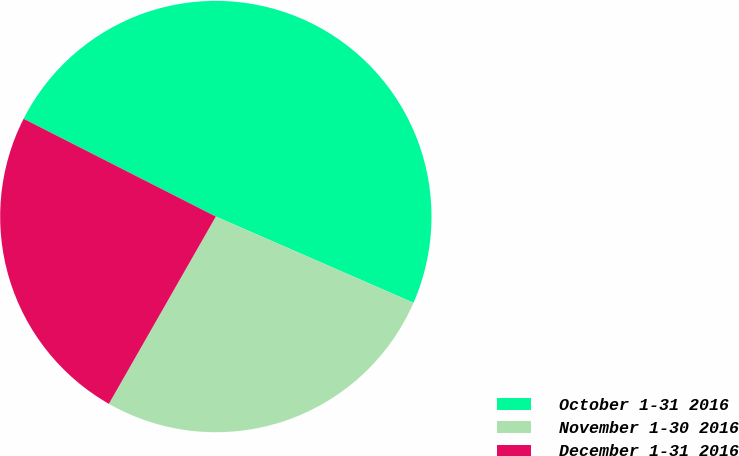Convert chart to OTSL. <chart><loc_0><loc_0><loc_500><loc_500><pie_chart><fcel>October 1-31 2016<fcel>November 1-30 2016<fcel>December 1-31 2016<nl><fcel>49.06%<fcel>26.71%<fcel>24.23%<nl></chart> 